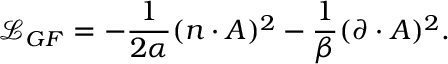Convert formula to latex. <formula><loc_0><loc_0><loc_500><loc_500>\mathcal { L } _ { G F } = - \frac { 1 } { 2 \alpha } ( n \cdot A ) ^ { 2 } - \frac { 1 } { \beta } ( \partial \cdot A ) ^ { 2 } .</formula> 